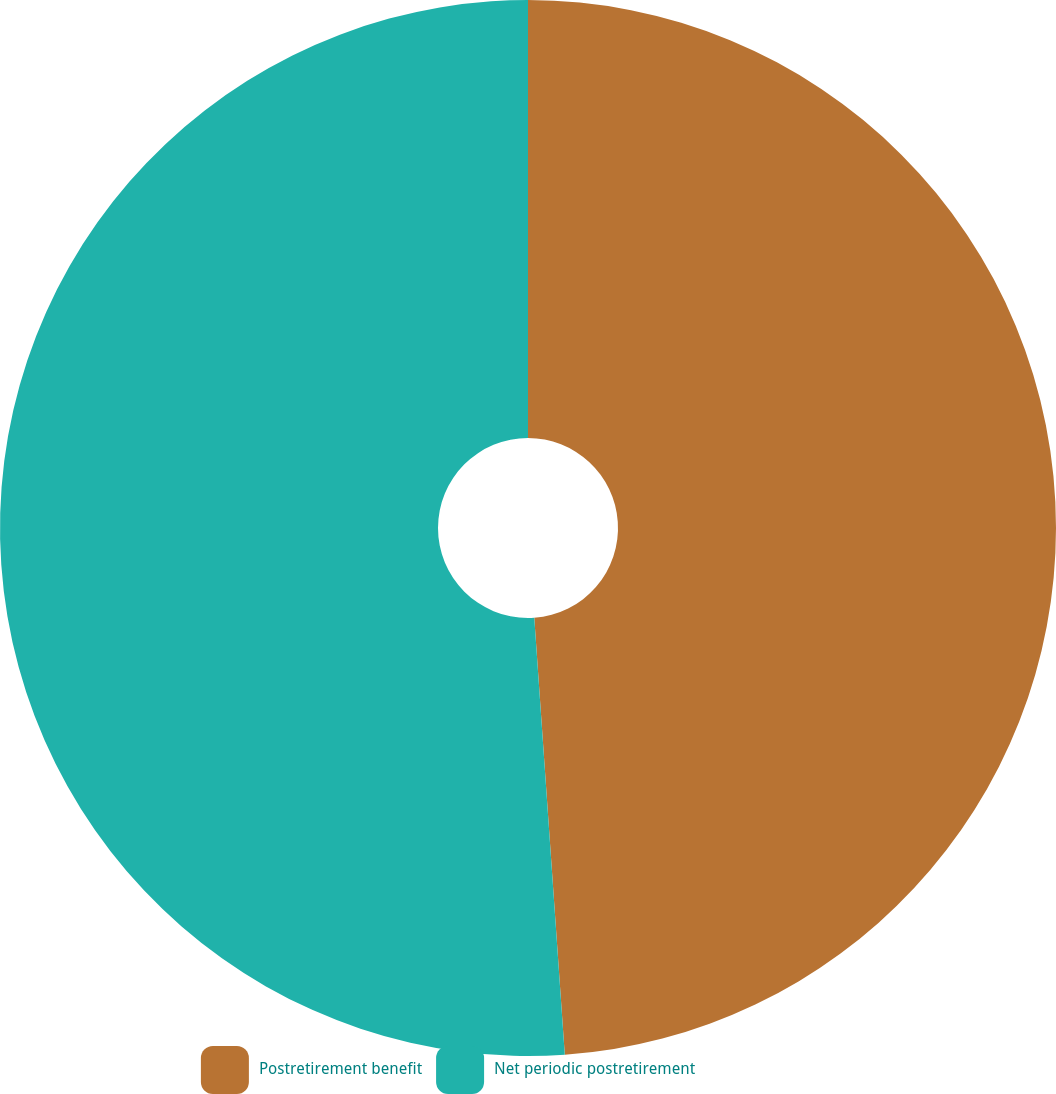Convert chart to OTSL. <chart><loc_0><loc_0><loc_500><loc_500><pie_chart><fcel>Postretirement benefit<fcel>Net periodic postretirement<nl><fcel>48.89%<fcel>51.11%<nl></chart> 